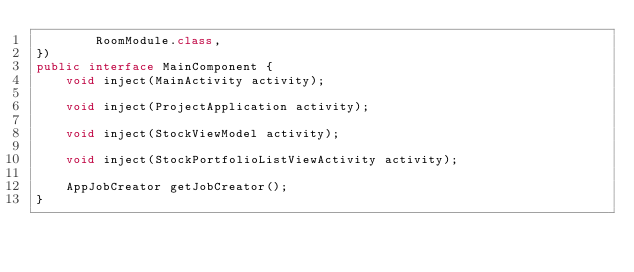<code> <loc_0><loc_0><loc_500><loc_500><_Java_>        RoomModule.class,
})
public interface MainComponent {
    void inject(MainActivity activity);

    void inject(ProjectApplication activity);

    void inject(StockViewModel activity);

    void inject(StockPortfolioListViewActivity activity);

    AppJobCreator getJobCreator();
}</code> 